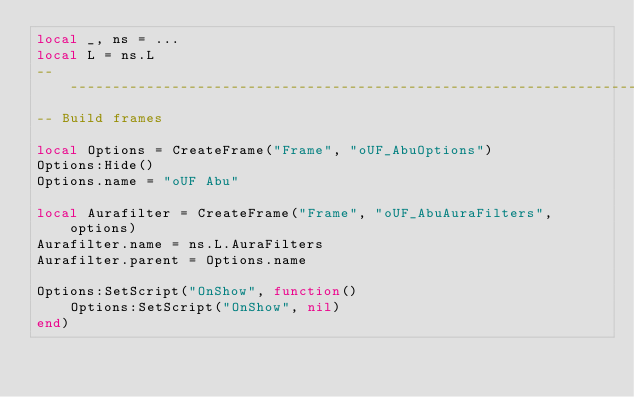Convert code to text. <code><loc_0><loc_0><loc_500><loc_500><_Lua_>local _, ns = ...
local L = ns.L
-----------------------------------------------------------------------------
-- Build frames

local Options = CreateFrame("Frame", "oUF_AbuOptions")
Options:Hide()
Options.name = "oUF Abu"

local Aurafilter = CreateFrame("Frame", "oUF_AbuAuraFilters", options)
Aurafilter.name = ns.L.AuraFilters
Aurafilter.parent = Options.name

Options:SetScript("OnShow", function()
	Options:SetScript("OnShow", nil)
end)
</code> 